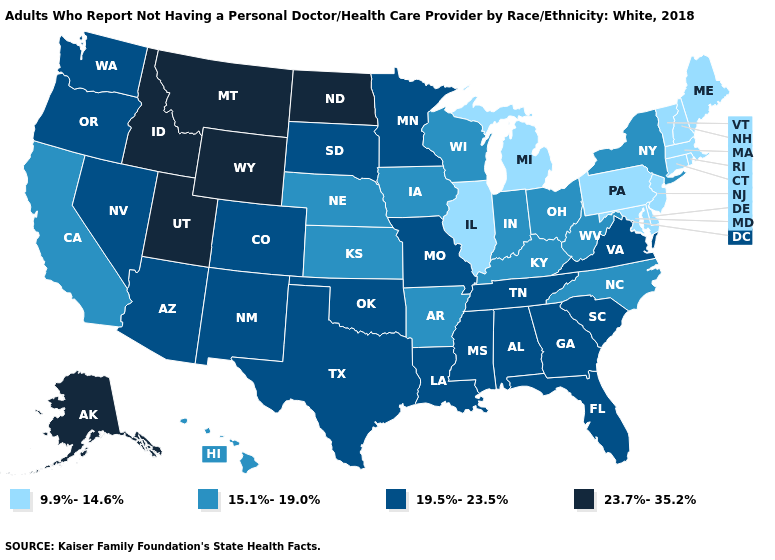What is the lowest value in the USA?
Short answer required. 9.9%-14.6%. What is the highest value in the South ?
Quick response, please. 19.5%-23.5%. Which states have the highest value in the USA?
Keep it brief. Alaska, Idaho, Montana, North Dakota, Utah, Wyoming. Does Kentucky have the lowest value in the USA?
Quick response, please. No. Is the legend a continuous bar?
Short answer required. No. Does Kansas have a lower value than South Carolina?
Quick response, please. Yes. Among the states that border Michigan , which have the highest value?
Give a very brief answer. Indiana, Ohio, Wisconsin. What is the value of Rhode Island?
Concise answer only. 9.9%-14.6%. Among the states that border New Jersey , which have the lowest value?
Be succinct. Delaware, Pennsylvania. Name the states that have a value in the range 19.5%-23.5%?
Be succinct. Alabama, Arizona, Colorado, Florida, Georgia, Louisiana, Minnesota, Mississippi, Missouri, Nevada, New Mexico, Oklahoma, Oregon, South Carolina, South Dakota, Tennessee, Texas, Virginia, Washington. What is the value of Mississippi?
Be succinct. 19.5%-23.5%. Name the states that have a value in the range 15.1%-19.0%?
Keep it brief. Arkansas, California, Hawaii, Indiana, Iowa, Kansas, Kentucky, Nebraska, New York, North Carolina, Ohio, West Virginia, Wisconsin. How many symbols are there in the legend?
Give a very brief answer. 4. Does Iowa have the lowest value in the USA?
Keep it brief. No. 